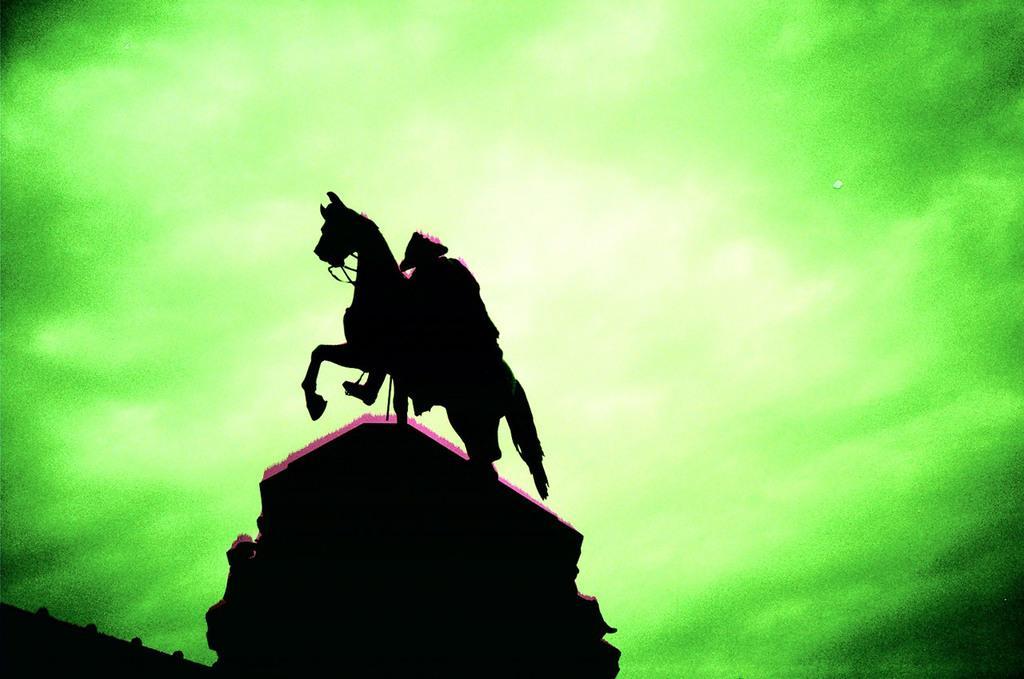Describe this image in one or two sentences. In this image there is a sculpture, in the background there is green color. 